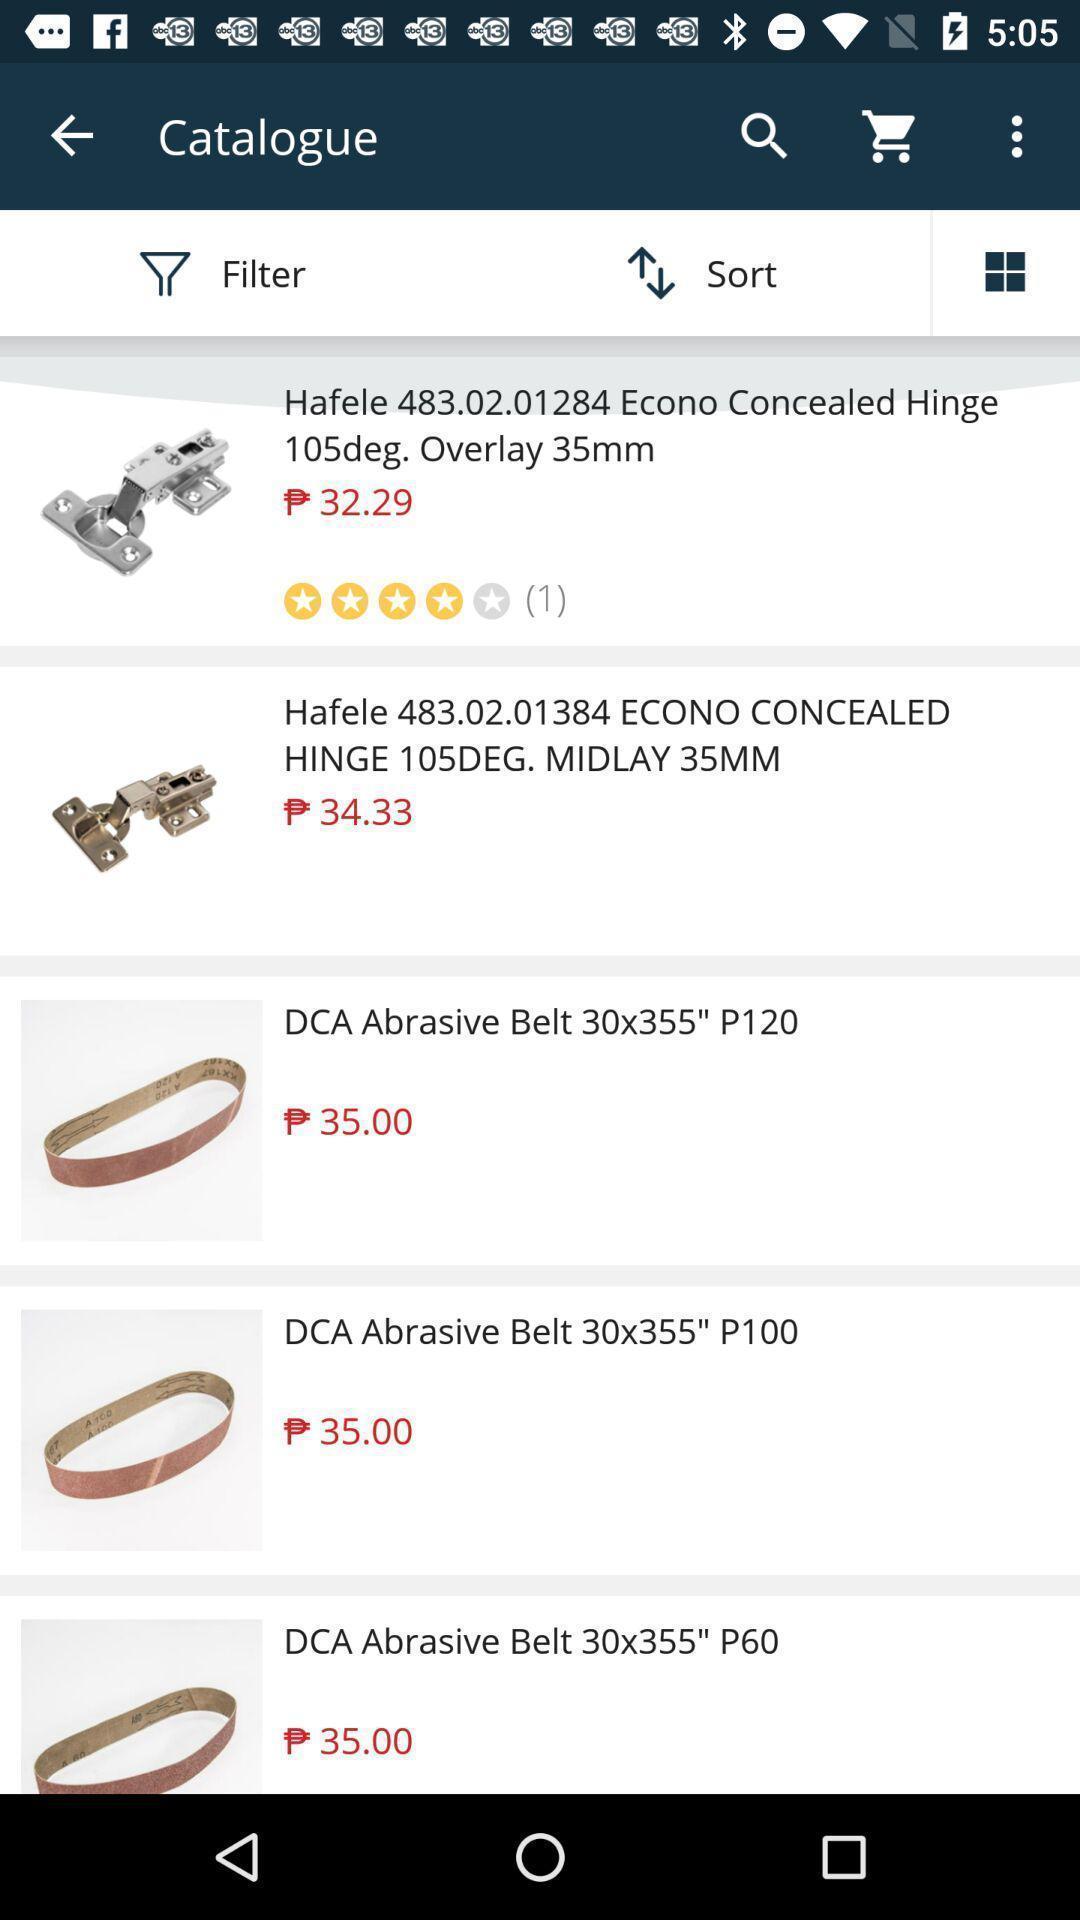What can you discern from this picture? Shopping app displayed catalogue of different items. 